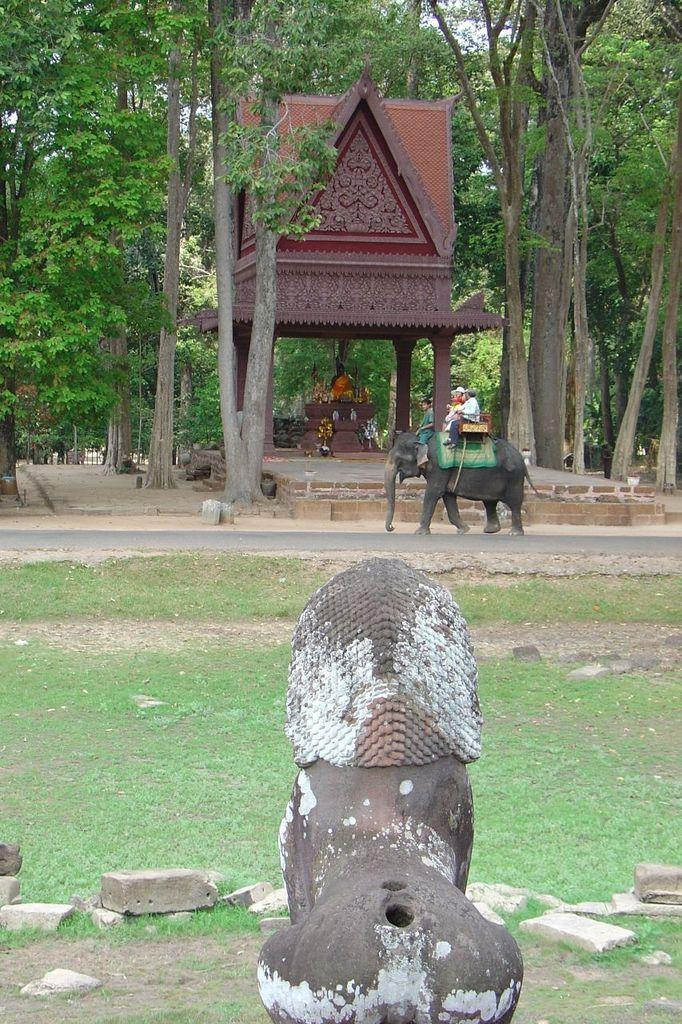What is located at the bottom of the image? There is a statue at the bottom of the image. What activity are the two people engaged in? The two people are sitting on an elephant in the image. What type of structure can be seen in the image? There is a temple in the image. What is inside the temple? The temple has a statue inside it. What is the surrounding environment of the temple? The temple is surrounded by trees. What type of clocks can be seen hanging on the walls of the temple? There are no clocks visible in the image; the focus is on the statue and the people sitting on the elephant. What type of soda is being served at the statue's feet in the image? There is no soda present in the image; the focus is on the statue and the surrounding environment. 